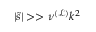<formula> <loc_0><loc_0><loc_500><loc_500>| \tilde { s } | > > \nu ^ { \mathcal { ( L ) } } k ^ { 2 }</formula> 